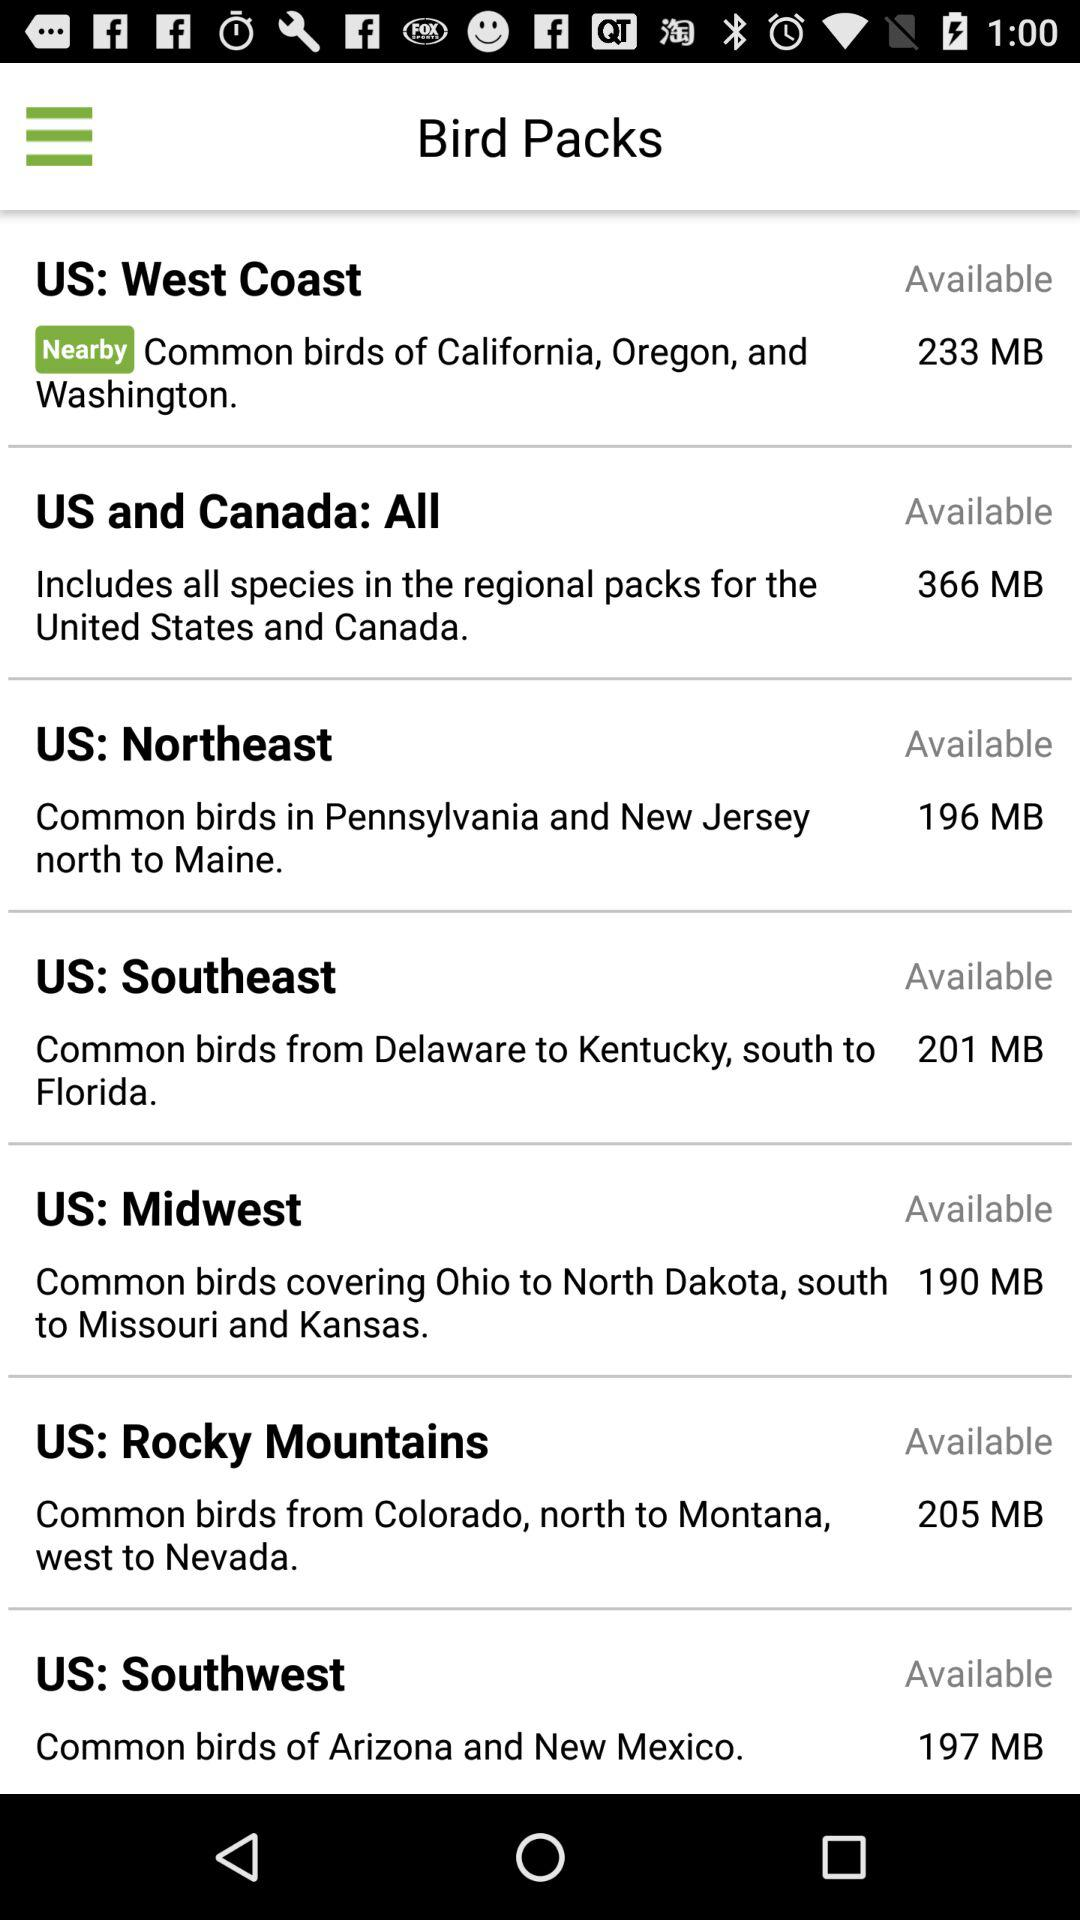How many MB is the largest bird pack?
Answer the question using a single word or phrase. 366 